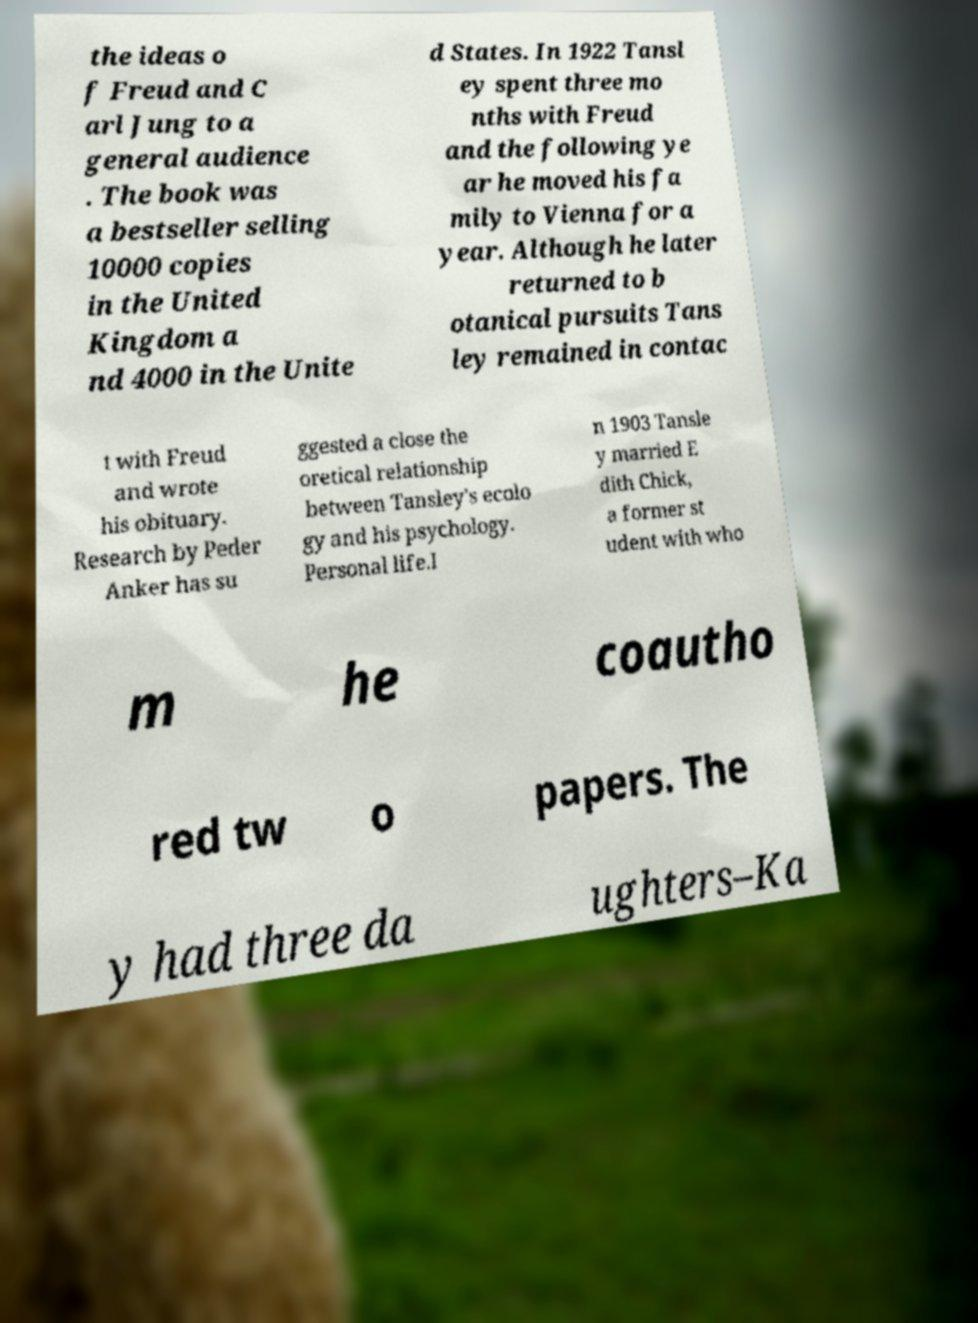I need the written content from this picture converted into text. Can you do that? the ideas o f Freud and C arl Jung to a general audience . The book was a bestseller selling 10000 copies in the United Kingdom a nd 4000 in the Unite d States. In 1922 Tansl ey spent three mo nths with Freud and the following ye ar he moved his fa mily to Vienna for a year. Although he later returned to b otanical pursuits Tans ley remained in contac t with Freud and wrote his obituary. Research by Peder Anker has su ggested a close the oretical relationship between Tansley's ecolo gy and his psychology. Personal life.I n 1903 Tansle y married E dith Chick, a former st udent with who m he coautho red tw o papers. The y had three da ughters–Ka 